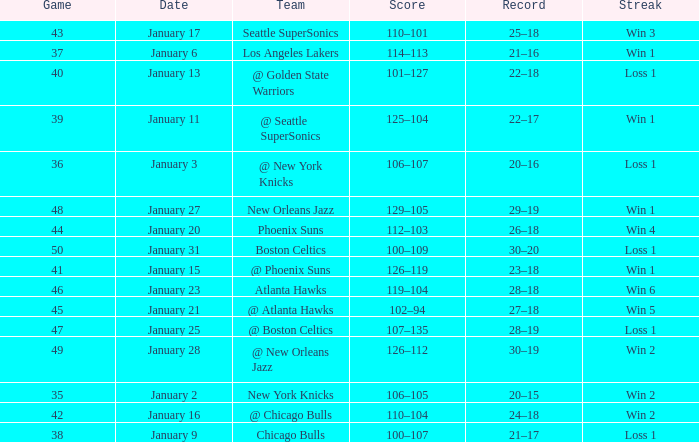What is the Team in Game 38? Chicago Bulls. 